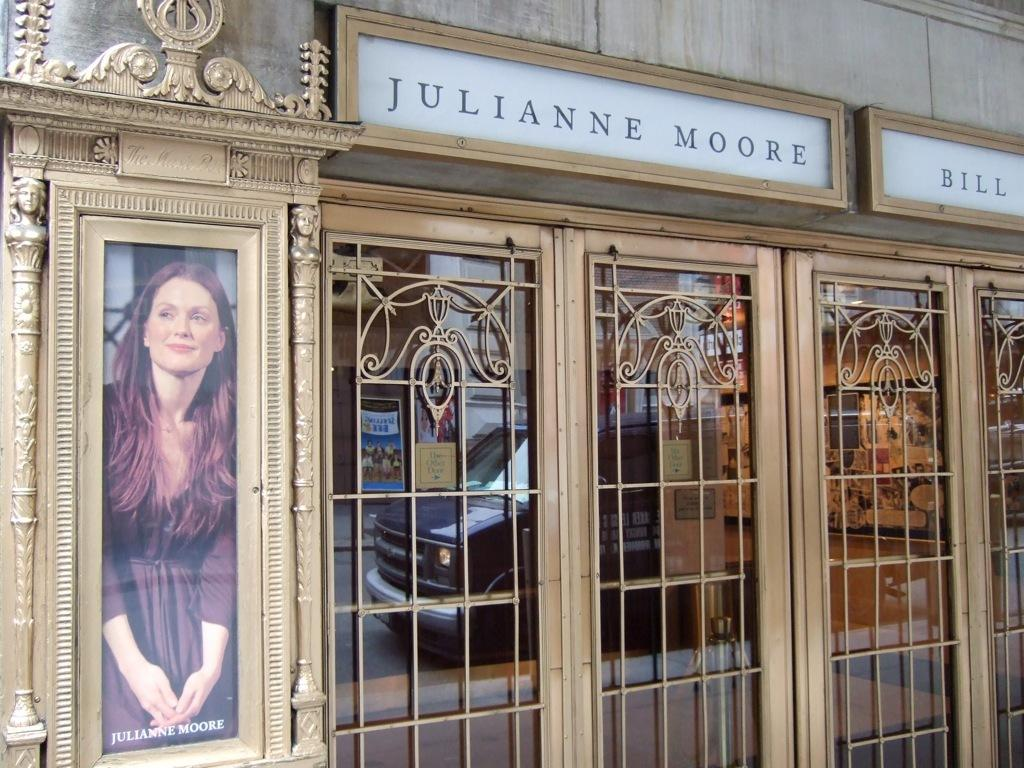What type of cooking appliance can be seen in the image? There are grills in the image. What material is present in the image that is typically transparent? There is glass in the image. What architectural feature is visible in the image that allows light to enter a room? There are windows in the image. What type of flat, rigid material can be seen in the image? There are boards in the image. What object in the image is used for displaying photographs? There is a photo frame in the image. What type of structure is visible in the image that separates spaces? There is a wall in the image. What type of vehicle is present in the image? There is a truck in the image. How does the spark from the train ignite the grills in the image? There are no trains present in the image, so there is no spark to ignite the grills. What level of expertise is required to use the beginner-friendly boards in the image? The boards in the image do not have any indication of being beginner-friendly, and the concept of expertise is not relevant to the image. 